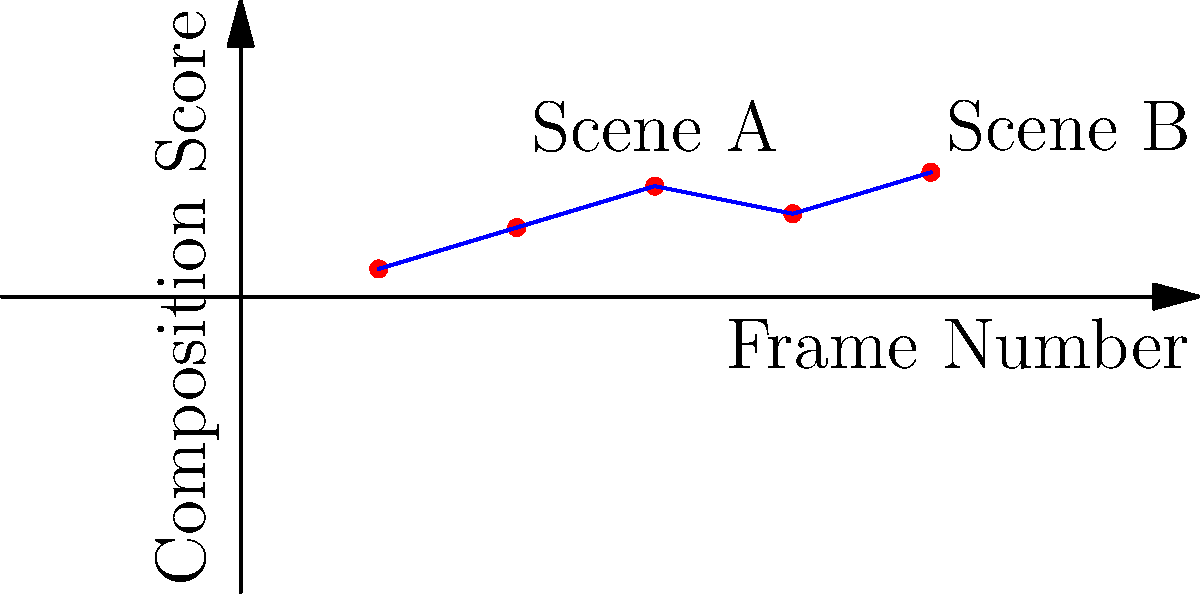Given the graph showing composition scores for a series of film frames, which machine learning technique would be most appropriate for predicting the composition score of the next frame in the sequence, and why? To answer this question, let's consider the following steps:

1. Analyze the data: The graph shows a time series of composition scores for consecutive film frames.

2. Identify the pattern: There's a clear sequential relationship between frames, with some variation in scores.

3. Consider the goal: We want to predict the next frame's composition score based on previous frames.

4. Evaluate machine learning techniques:
   a) Linear Regression: Not ideal for capturing complex temporal patterns.
   b) Decision Trees: Struggle with continuous, sequential data.
   c) Recurrent Neural Networks (RNNs): Designed for sequential data but can be complex.
   d) Long Short-Term Memory (LSTM): A type of RNN, good for longer sequences.
   e) Time Series Forecasting models (e.g., ARIMA): Specifically designed for time-based predictions.

5. Choose the best technique: LSTM networks are well-suited for this task because:
   - They can capture long-term dependencies in sequential data.
   - They're effective at learning patterns in time series data.
   - They can handle the variability seen in the composition scores.
   - They're commonly used in video analysis tasks in the film industry.

6. Implementation consideration: LSTMs can be trained on sequences of frame composition scores to predict the next frame's score, taking into account the temporal nature of film scenes.
Answer: Long Short-Term Memory (LSTM) networks 